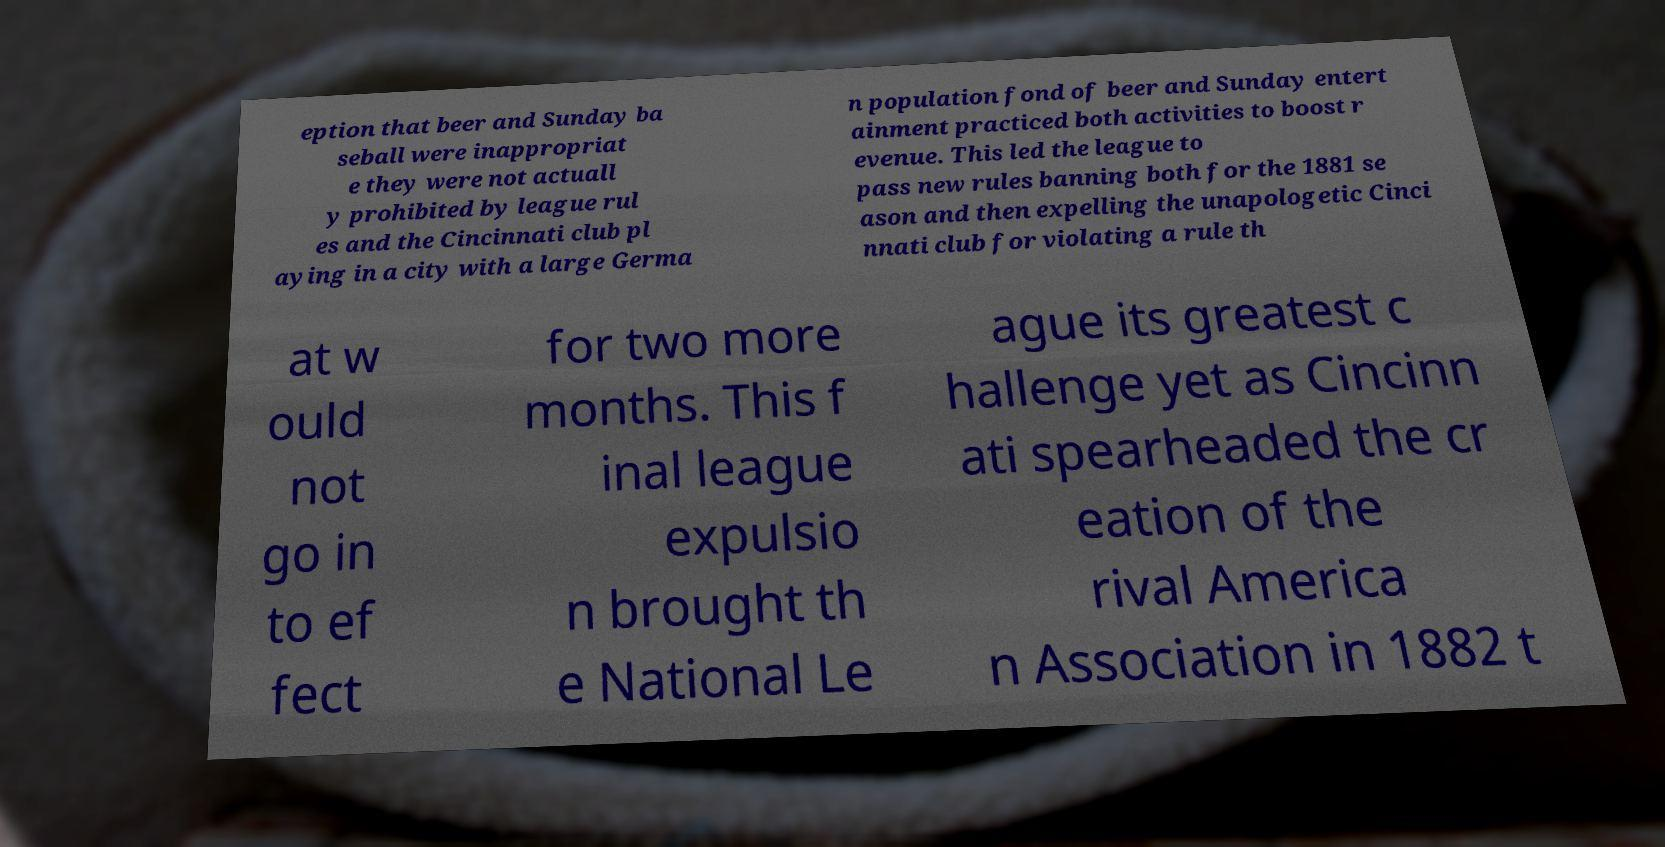Can you accurately transcribe the text from the provided image for me? eption that beer and Sunday ba seball were inappropriat e they were not actuall y prohibited by league rul es and the Cincinnati club pl aying in a city with a large Germa n population fond of beer and Sunday entert ainment practiced both activities to boost r evenue. This led the league to pass new rules banning both for the 1881 se ason and then expelling the unapologetic Cinci nnati club for violating a rule th at w ould not go in to ef fect for two more months. This f inal league expulsio n brought th e National Le ague its greatest c hallenge yet as Cincinn ati spearheaded the cr eation of the rival America n Association in 1882 t 